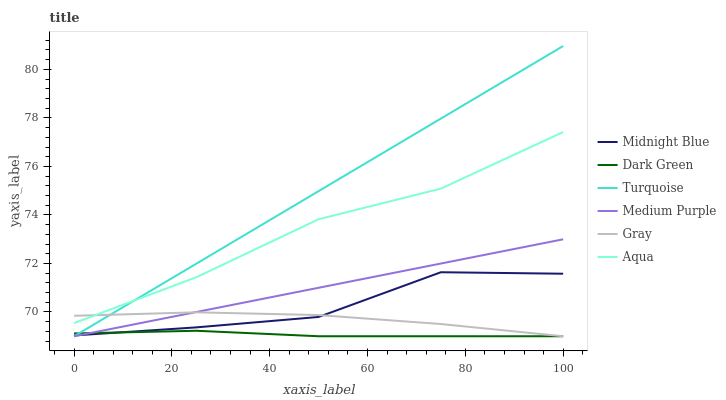Does Dark Green have the minimum area under the curve?
Answer yes or no. Yes. Does Turquoise have the maximum area under the curve?
Answer yes or no. Yes. Does Midnight Blue have the minimum area under the curve?
Answer yes or no. No. Does Midnight Blue have the maximum area under the curve?
Answer yes or no. No. Is Turquoise the smoothest?
Answer yes or no. Yes. Is Midnight Blue the roughest?
Answer yes or no. Yes. Is Midnight Blue the smoothest?
Answer yes or no. No. Is Turquoise the roughest?
Answer yes or no. No. Does Gray have the lowest value?
Answer yes or no. Yes. Does Midnight Blue have the lowest value?
Answer yes or no. No. Does Turquoise have the highest value?
Answer yes or no. Yes. Does Midnight Blue have the highest value?
Answer yes or no. No. Is Dark Green less than Aqua?
Answer yes or no. Yes. Is Aqua greater than Dark Green?
Answer yes or no. Yes. Does Medium Purple intersect Midnight Blue?
Answer yes or no. Yes. Is Medium Purple less than Midnight Blue?
Answer yes or no. No. Is Medium Purple greater than Midnight Blue?
Answer yes or no. No. Does Dark Green intersect Aqua?
Answer yes or no. No. 